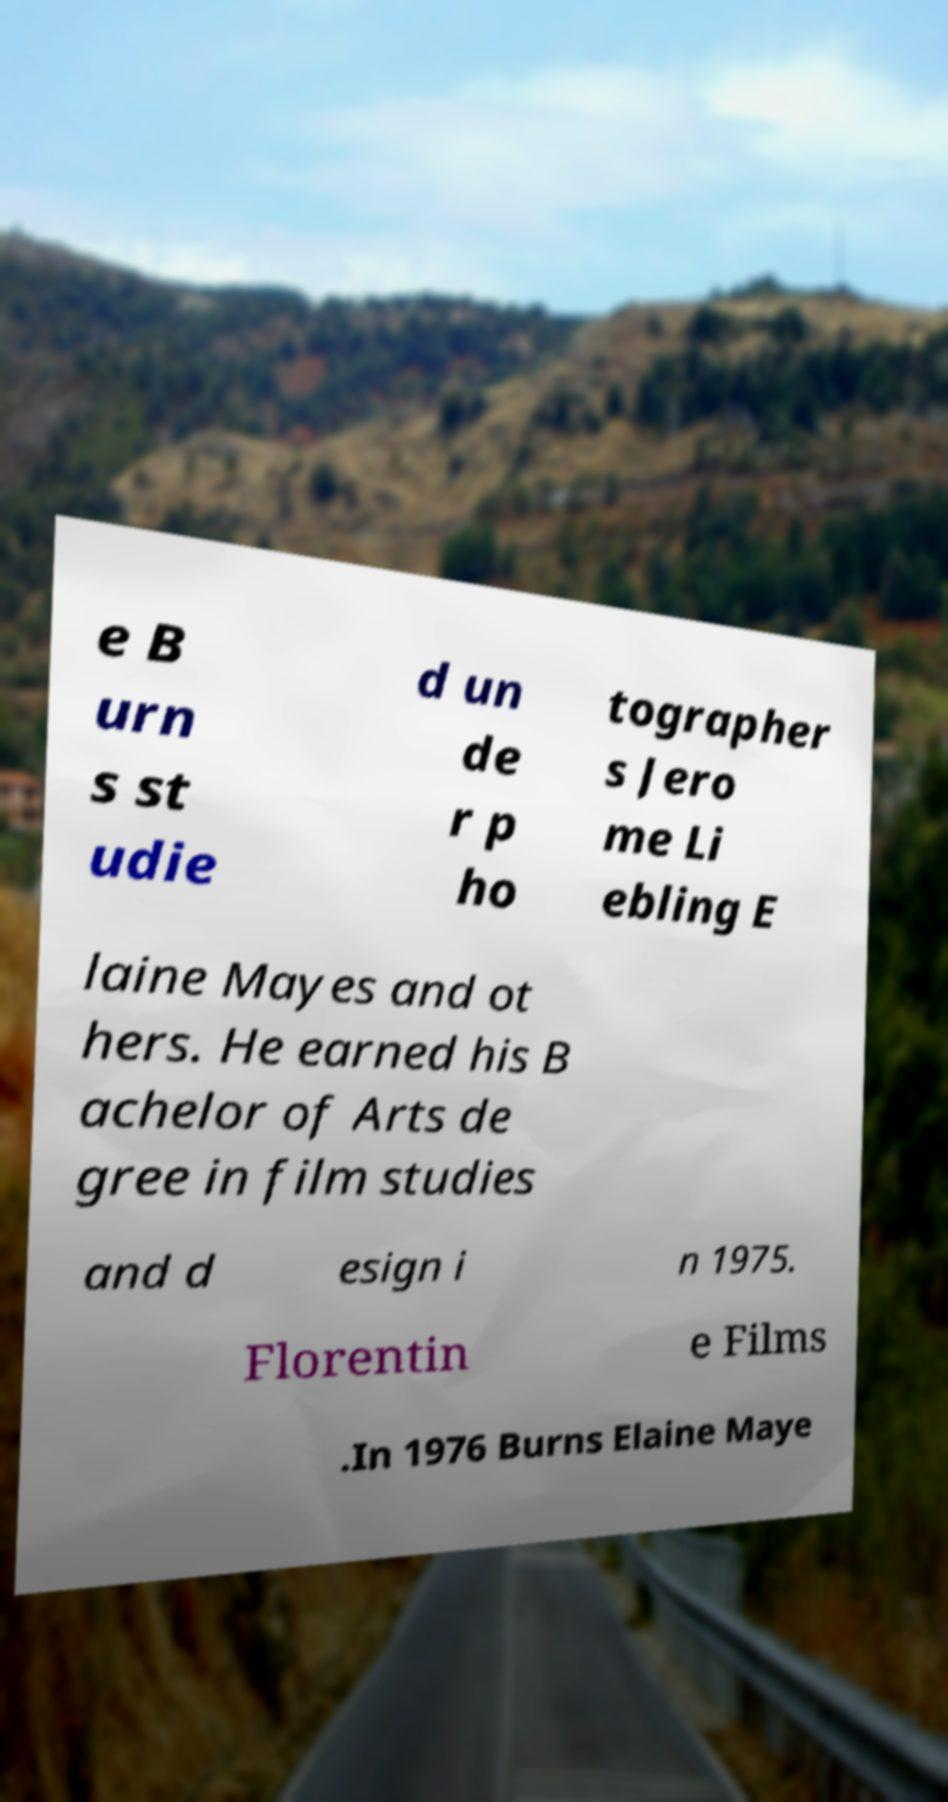Please read and relay the text visible in this image. What does it say? e B urn s st udie d un de r p ho tographer s Jero me Li ebling E laine Mayes and ot hers. He earned his B achelor of Arts de gree in film studies and d esign i n 1975. Florentin e Films .In 1976 Burns Elaine Maye 